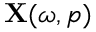<formula> <loc_0><loc_0><loc_500><loc_500>X ( \omega , p )</formula> 